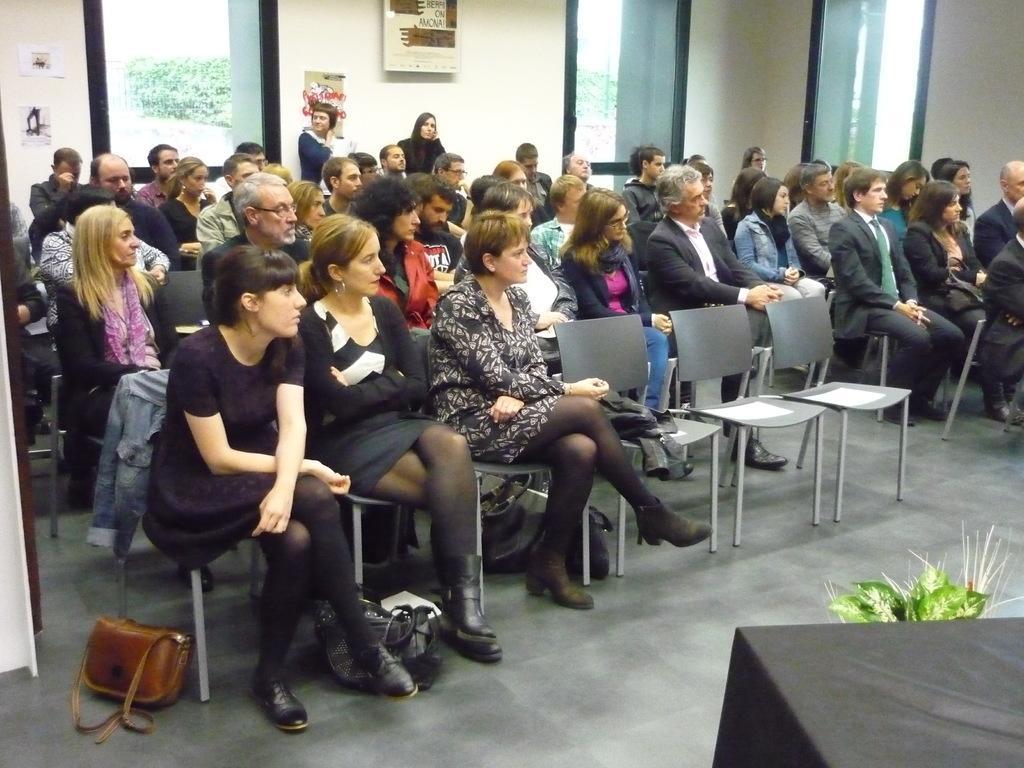In one or two sentences, can you explain what this image depicts? In this image we can see many people sitting on the chairs. This is the flower pot, handbag, glass window through which trees can be seen. 